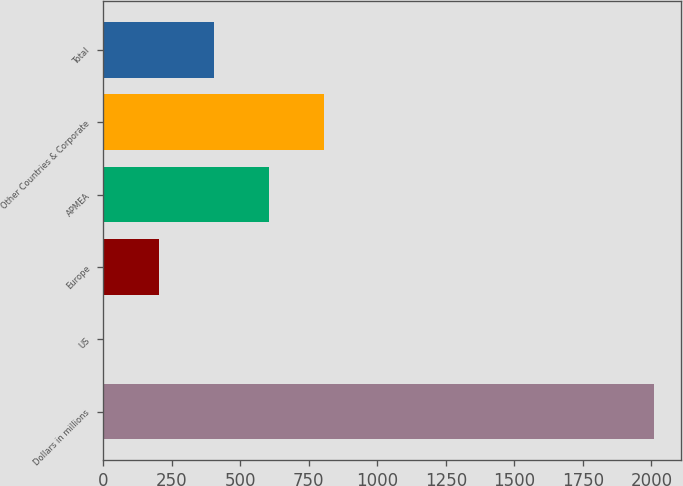Convert chart. <chart><loc_0><loc_0><loc_500><loc_500><bar_chart><fcel>Dollars in millions<fcel>US<fcel>Europe<fcel>APMEA<fcel>Other Countries & Corporate<fcel>Total<nl><fcel>2008<fcel>1<fcel>201.7<fcel>603.1<fcel>803.8<fcel>402.4<nl></chart> 